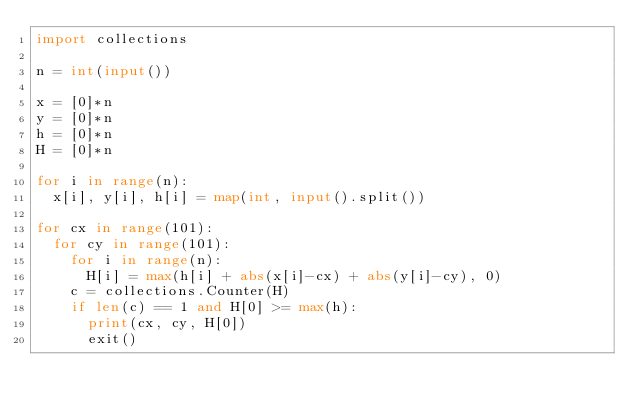<code> <loc_0><loc_0><loc_500><loc_500><_Python_>import collections

n = int(input())

x = [0]*n
y = [0]*n
h = [0]*n
H = [0]*n

for i in range(n):
  x[i], y[i], h[i] = map(int, input().split())
  
for cx in range(101):
  for cy in range(101):
    for i in range(n):
      H[i] = max(h[i] + abs(x[i]-cx) + abs(y[i]-cy), 0)
    c = collections.Counter(H)
    if len(c) == 1 and H[0] >= max(h):
      print(cx, cy, H[0])
      exit()</code> 